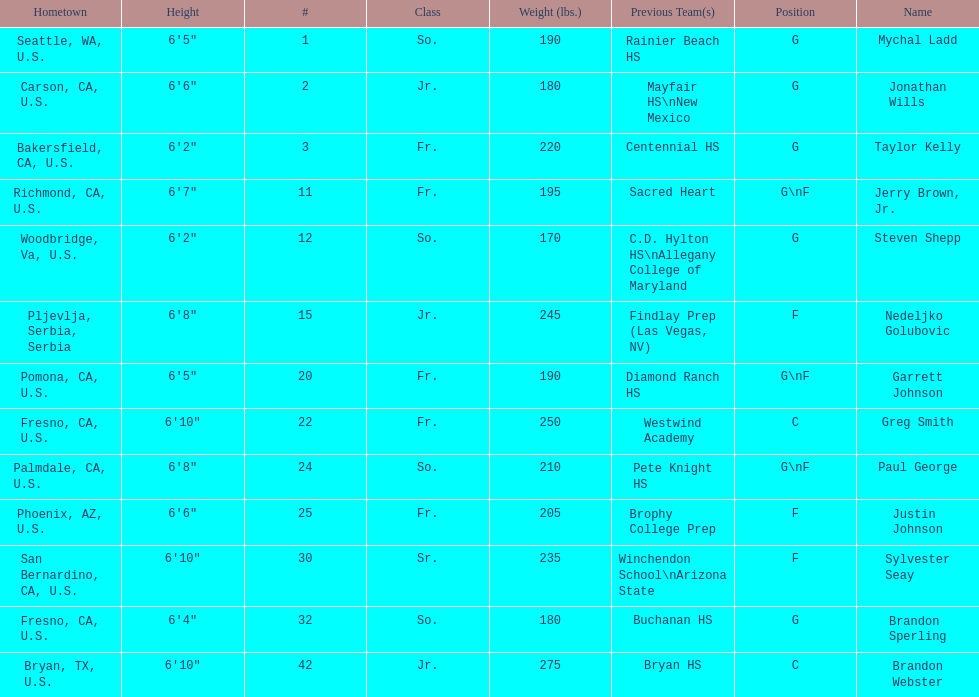I'm looking to parse the entire table for insights. Could you assist me with that? {'header': ['Hometown', 'Height', '#', 'Class', 'Weight (lbs.)', 'Previous Team(s)', 'Position', 'Name'], 'rows': [['Seattle, WA, U.S.', '6\'5"', '1', 'So.', '190', 'Rainier Beach HS', 'G', 'Mychal Ladd'], ['Carson, CA, U.S.', '6\'6"', '2', 'Jr.', '180', 'Mayfair HS\\nNew Mexico', 'G', 'Jonathan Wills'], ['Bakersfield, CA, U.S.', '6\'2"', '3', 'Fr.', '220', 'Centennial HS', 'G', 'Taylor Kelly'], ['Richmond, CA, U.S.', '6\'7"', '11', 'Fr.', '195', 'Sacred Heart', 'G\\nF', 'Jerry Brown, Jr.'], ['Woodbridge, Va, U.S.', '6\'2"', '12', 'So.', '170', 'C.D. Hylton HS\\nAllegany College of Maryland', 'G', 'Steven Shepp'], ['Pljevlja, Serbia, Serbia', '6\'8"', '15', 'Jr.', '245', 'Findlay Prep (Las Vegas, NV)', 'F', 'Nedeljko Golubovic'], ['Pomona, CA, U.S.', '6\'5"', '20', 'Fr.', '190', 'Diamond Ranch HS', 'G\\nF', 'Garrett Johnson'], ['Fresno, CA, U.S.', '6\'10"', '22', 'Fr.', '250', 'Westwind Academy', 'C', 'Greg Smith'], ['Palmdale, CA, U.S.', '6\'8"', '24', 'So.', '210', 'Pete Knight HS', 'G\\nF', 'Paul George'], ['Phoenix, AZ, U.S.', '6\'6"', '25', 'Fr.', '205', 'Brophy College Prep', 'F', 'Justin Johnson'], ['San Bernardino, CA, U.S.', '6\'10"', '30', 'Sr.', '235', 'Winchendon School\\nArizona State', 'F', 'Sylvester Seay'], ['Fresno, CA, U.S.', '6\'4"', '32', 'So.', '180', 'Buchanan HS', 'G', 'Brandon Sperling'], ['Bryan, TX, U.S.', '6\'10"', '42', 'Jr.', '275', 'Bryan HS', 'C', 'Brandon Webster']]} Is the number of freshmen (fr.) greater than, equal to, or less than the number of juniors (jr.)? Greater. 